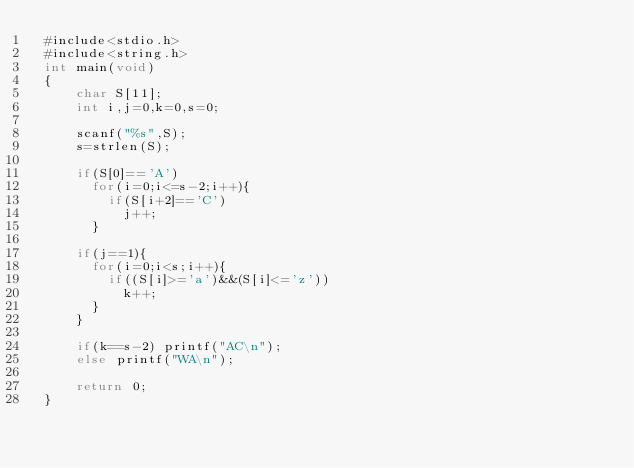<code> <loc_0><loc_0><loc_500><loc_500><_C_> #include<stdio.h>
 #include<string.h>
 int main(void)
 {
     char S[11];
     int i,j=0,k=0,s=0;

     scanf("%s",S);
     s=strlen(S);

     if(S[0]=='A')
       for(i=0;i<=s-2;i++){
         if(S[i+2]=='C')
           j++;
       }

     if(j==1){
       for(i=0;i<s;i++){
         if((S[i]>='a')&&(S[i]<='z'))
           k++;
       }
     }

     if(k==s-2) printf("AC\n");
     else printf("WA\n");

     return 0;
 }
</code> 